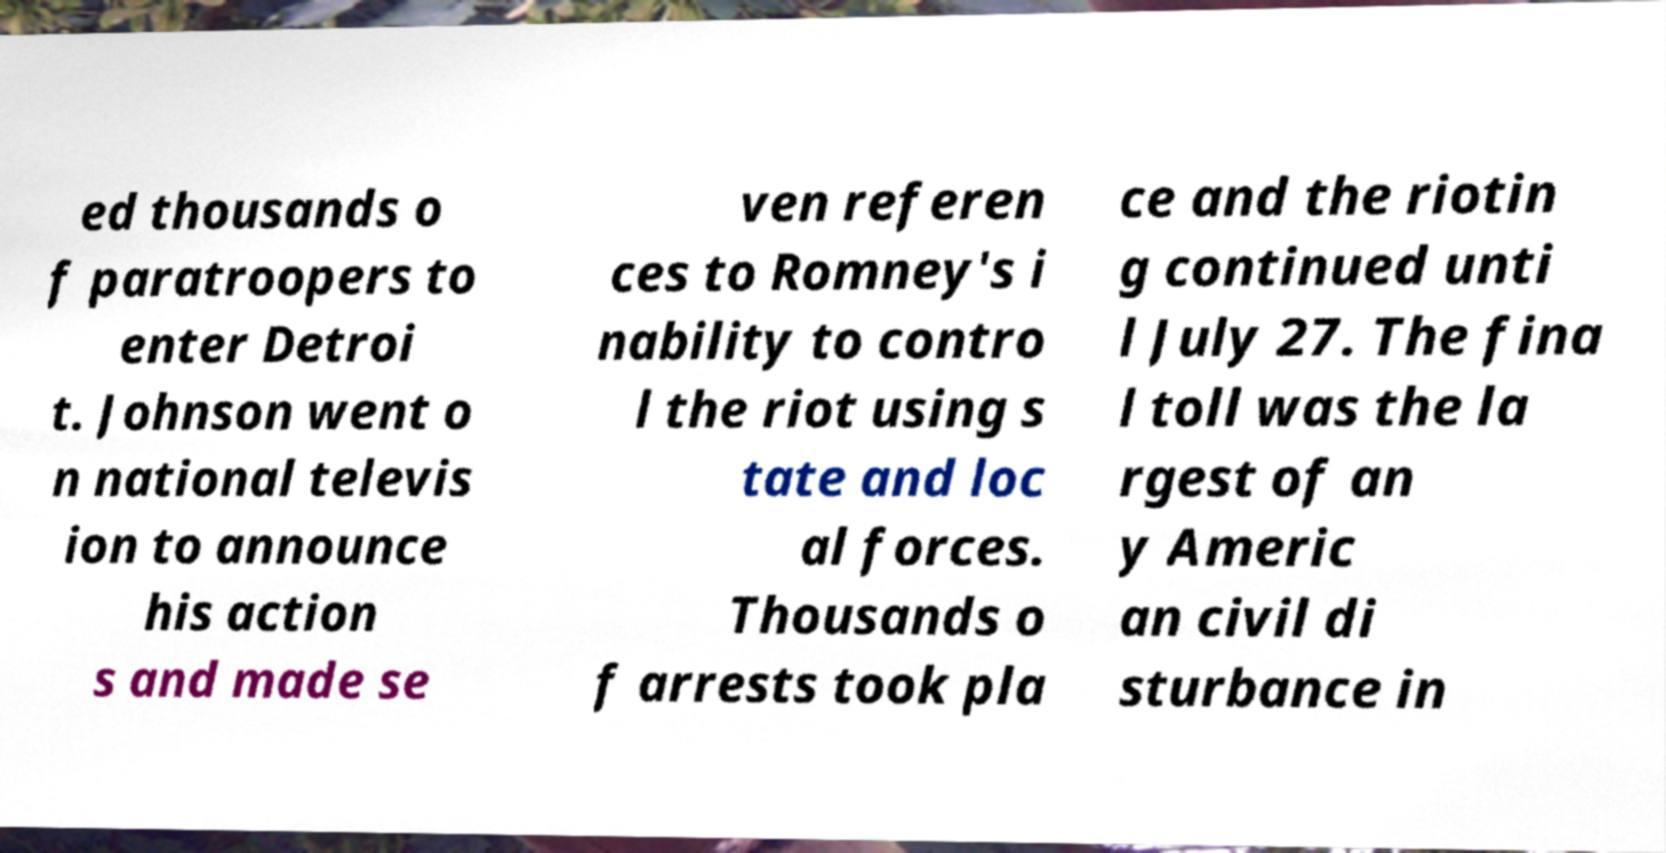Please read and relay the text visible in this image. What does it say? ed thousands o f paratroopers to enter Detroi t. Johnson went o n national televis ion to announce his action s and made se ven referen ces to Romney's i nability to contro l the riot using s tate and loc al forces. Thousands o f arrests took pla ce and the riotin g continued unti l July 27. The fina l toll was the la rgest of an y Americ an civil di sturbance in 